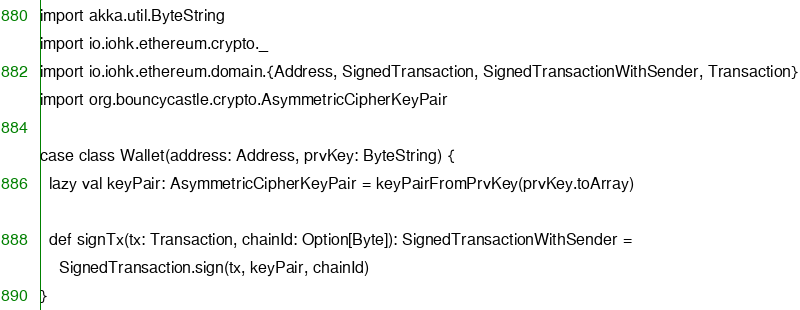<code> <loc_0><loc_0><loc_500><loc_500><_Scala_>
import akka.util.ByteString
import io.iohk.ethereum.crypto._
import io.iohk.ethereum.domain.{Address, SignedTransaction, SignedTransactionWithSender, Transaction}
import org.bouncycastle.crypto.AsymmetricCipherKeyPair

case class Wallet(address: Address, prvKey: ByteString) {
  lazy val keyPair: AsymmetricCipherKeyPair = keyPairFromPrvKey(prvKey.toArray)

  def signTx(tx: Transaction, chainId: Option[Byte]): SignedTransactionWithSender =
    SignedTransaction.sign(tx, keyPair, chainId)
}
</code> 